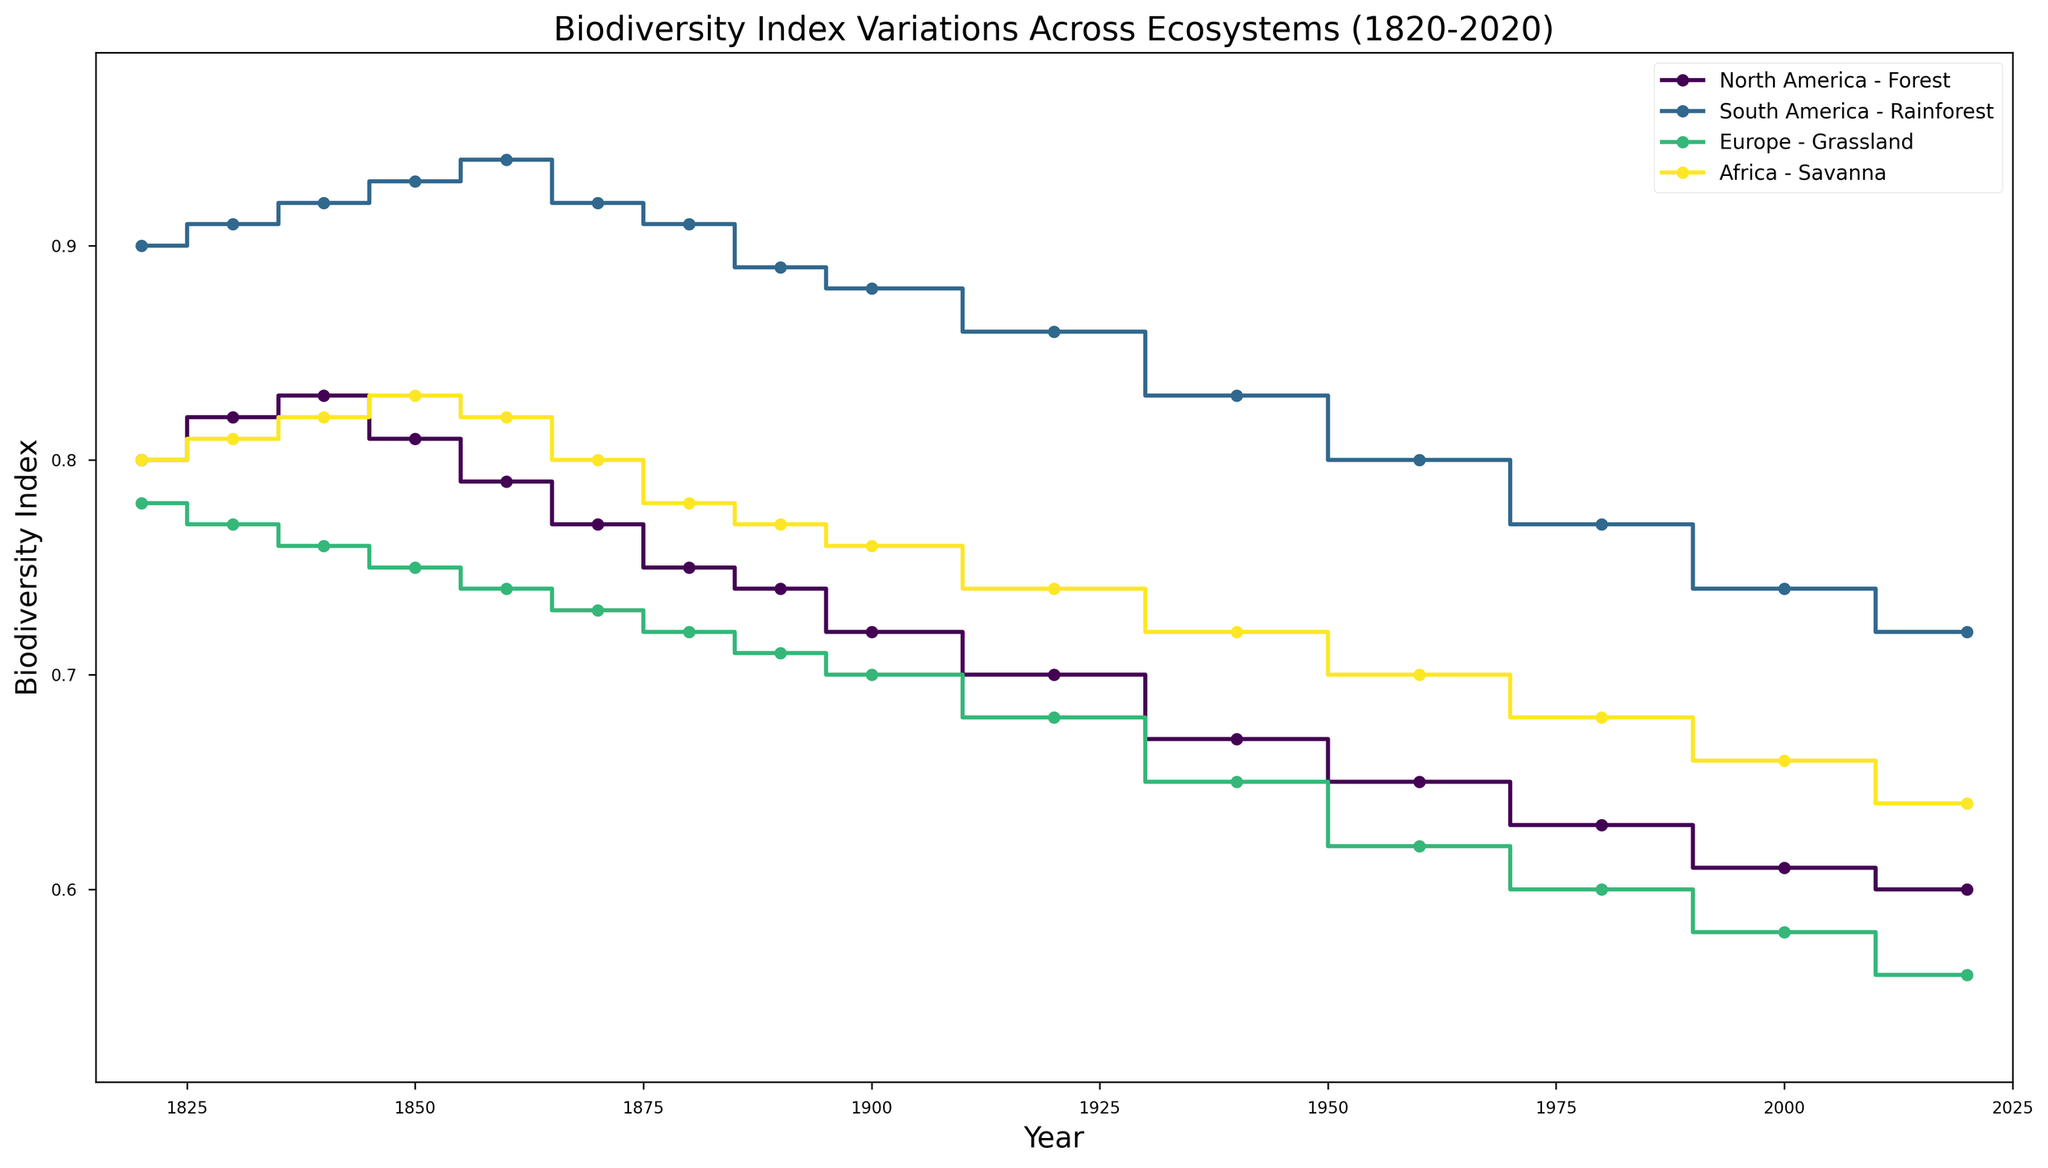Which region and ecosystem had the highest biodiversity index in the year 1820? To answer this, look at the y-axis values for the year 1820 across all regions and ecosystems. The highest value is 0.90, which corresponds to South America - Rainforest.
Answer: South America - Rainforest How did the biodiversity index change for North America's Forest from 1820 to 2020? To answer, subtract the biodiversity index of 2020 from that of 1820 for North America's Forest. The index changes from 0.80 in 1820 to 0.60 in 2020, so the change is 0.80 - 0.60.
Answer: -0.20 Which two ecosystems had the closest biodiversity indices in 1900, and what were those values? Compare the biodiversity indices of all ecosystems in 1900. Both North America's Forest and Africa's Savanna have indices very close to each other, with values of 0.72 and 0.76 respectively. The difference is 0.04.
Answer: North America's Forest and Africa's Savanna (0.72 and 0.76) What is the trend of the biodiversity index in South America - Rainforest from 1850 to 2000? Examine the points year-wise from 1850 to 2000 for South America - Rainforest. The index starts at 0.93 in 1850 and decreases to 0.74 by 2000, indicating a downward trend.
Answer: Downward Between Europe - Grassland and Africa - Savanna, which experienced a larger decline in biodiversity index over the last 200 years? Calculate the difference in biodiversity index from 1820 to 2020 for both regions. For Europe - Grassland, it's 0.78 - 0.56 = 0.22. For Africa - Savanna, it's 0.80 - 0.64 = 0.16. Europe - Grassland experienced a larger decline.
Answer: Europe - Grassland What is the average biodiversity index in 2020 across all regions and ecosystems? Sum the biodiversity indices for 2020 across all regions and ecosystems and divide by the number of data points. The sum is 0.60 + 0.72 + 0.56 + 0.64 = 2.52. There are 4 data points, so the average is 2.52 / 4.
Answer: 0.63 In which decade did South America's Rainforest experience the greatest single drop in biodiversity index? Identify the largest drop by comparing consecutive decade values for South America's Rainforest. The largest drop occurs between 1850 (0.93) and 1860 (0.94), which is a drop of 0.02.
Answer: 1870s Which ecosystem shows the least variation in biodiversity index over the given period and what might this indicate? Compare the range of biodiversity index for each ecosystem from start to end. Africa - Savanna varies from 0.8 to 0.64, making it the least varied ecosystem. Less variation might indicate more stability or different environmental pressures.
Answer: Africa - Savanna - Stable ecosystem/environmental pressures 